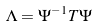<formula> <loc_0><loc_0><loc_500><loc_500>\Lambda = \Psi ^ { - 1 } T \Psi</formula> 